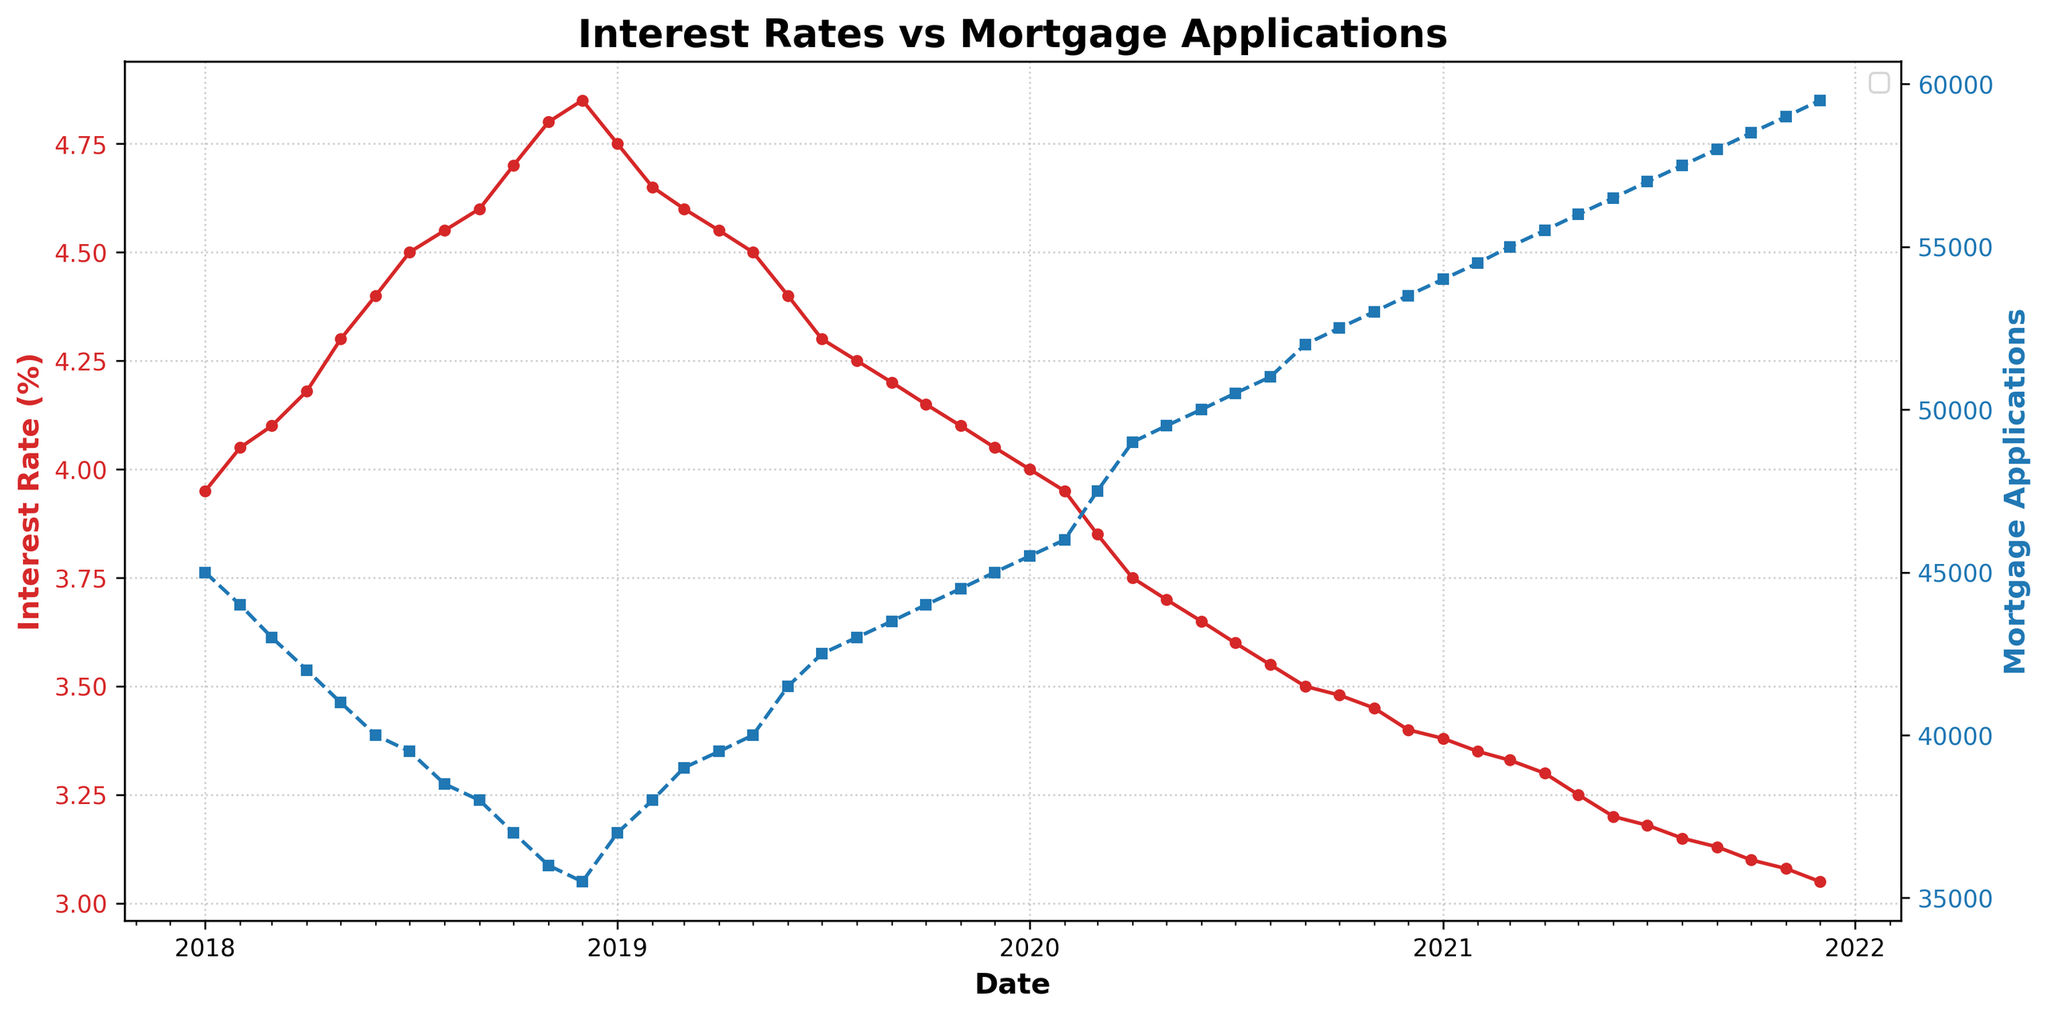What is the title of the figure? The title is located at the top center of the figure. It reads 'Interest Rates vs Mortgage Applications'.
Answer: Interest Rates vs Mortgage Applications What color is used to represent the interest rate line in the figure? The interest rate line is marked in red throughout the plot. This can be observed by looking at the red line on the left y-axis.
Answer: Red How many years of data are shown in the figure? The x-axis displays data from January 2018 to December 2021. By counting the years, we have data for four years: 2018, 2019, 2020, and 2021.
Answer: 4 In which month was the maximum number of mortgage applications recorded? By observing the blue dashed line representing mortgage applications, the maximum point occurs in September 2021, where the number of applications was 58,000.
Answer: September 2021 Which month shows the highest interest rate in the figure? The highest point on the red interest rate line occurs in December 2018, marked as 4.85%.
Answer: December 2018 What was the trend of mortgage applications between January 2018 and December 2018? Mortgage applications displayed a declining trend; starting from about 45,000 in January and dropping to approximately 35,500 by December 2018.
Answer: Declining Trend Did the interest rate decrease consistently from January 2019 to December 2021? The interest rate shows a decreasing trend, though it fluctuates slightly at several points, overall it starts at 4.75% in January 2019 and drops to 3.05% by December 2021.
Answer: Yes Which year experienced the most significant overall decrease in interest rates? By examining the red line year by year, 2020 shows the most considerable drop in interest rates from 3.95% in January 2020 to 3.40% in December 2020.
Answer: 2020 What can you infer from the relationship between interest rates and mortgage applications? Generally, as the interest rate decreases, mortgage applications increase. This is evident from the opposing trends: the red line (interest rates) decreases, while the blue dashed line (mortgage applications) increases.
Answer: Inverse Relationship How does the number of mortgage applications in January 2019 compare with June 2021? In January 2019, the number of mortgage applications was about 37,000, whereas in June 2021, it was approximately 56,500, indicating a significant increase.
Answer: Much Higher in June 2021 